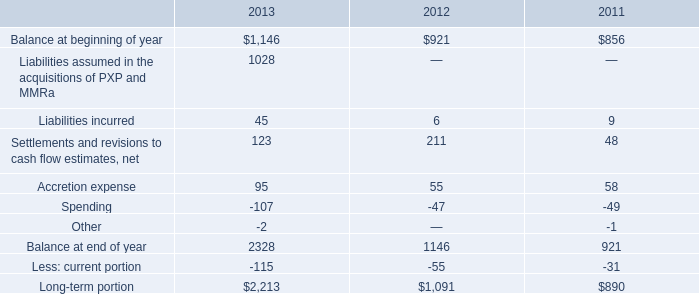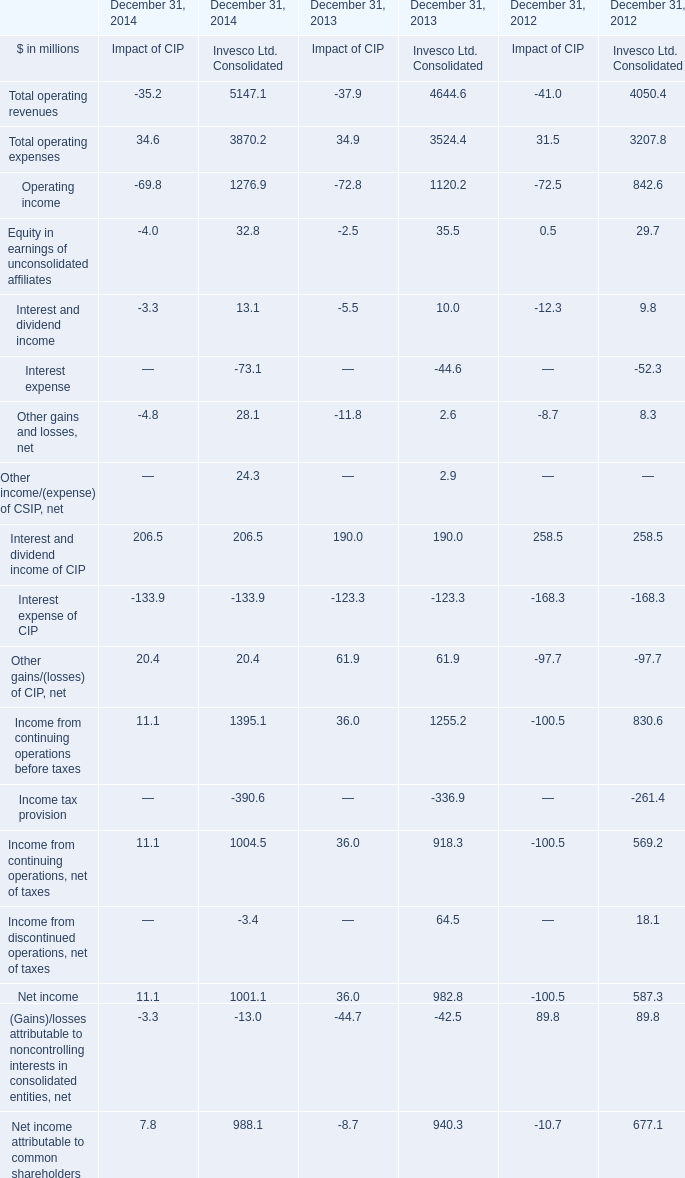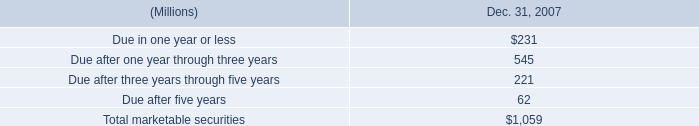What's the total amount of the Interest and dividend income for Invesco Ltd. Consolidated in the years where Balance at beginning of year is greater than 900? (in million) 
Computations: (10.0 + 9.8)
Answer: 19.8. 